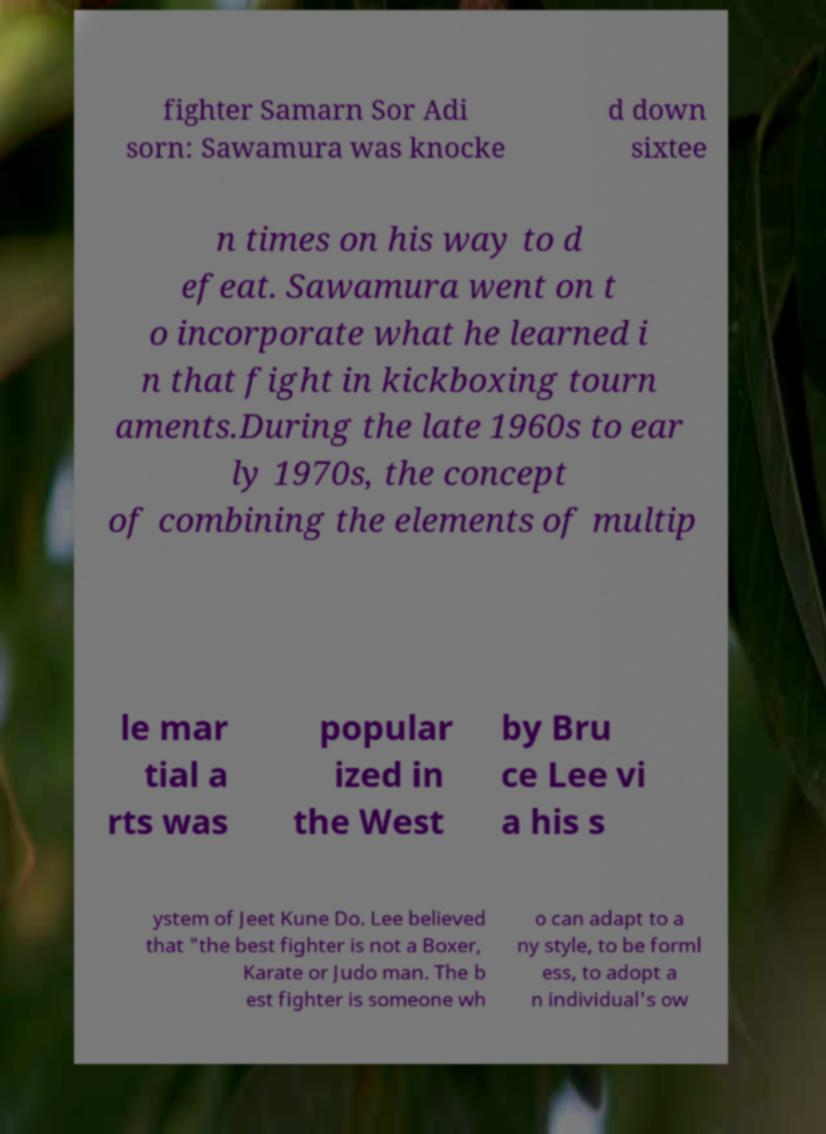There's text embedded in this image that I need extracted. Can you transcribe it verbatim? fighter Samarn Sor Adi sorn: Sawamura was knocke d down sixtee n times on his way to d efeat. Sawamura went on t o incorporate what he learned i n that fight in kickboxing tourn aments.During the late 1960s to ear ly 1970s, the concept of combining the elements of multip le mar tial a rts was popular ized in the West by Bru ce Lee vi a his s ystem of Jeet Kune Do. Lee believed that "the best fighter is not a Boxer, Karate or Judo man. The b est fighter is someone wh o can adapt to a ny style, to be forml ess, to adopt a n individual's ow 